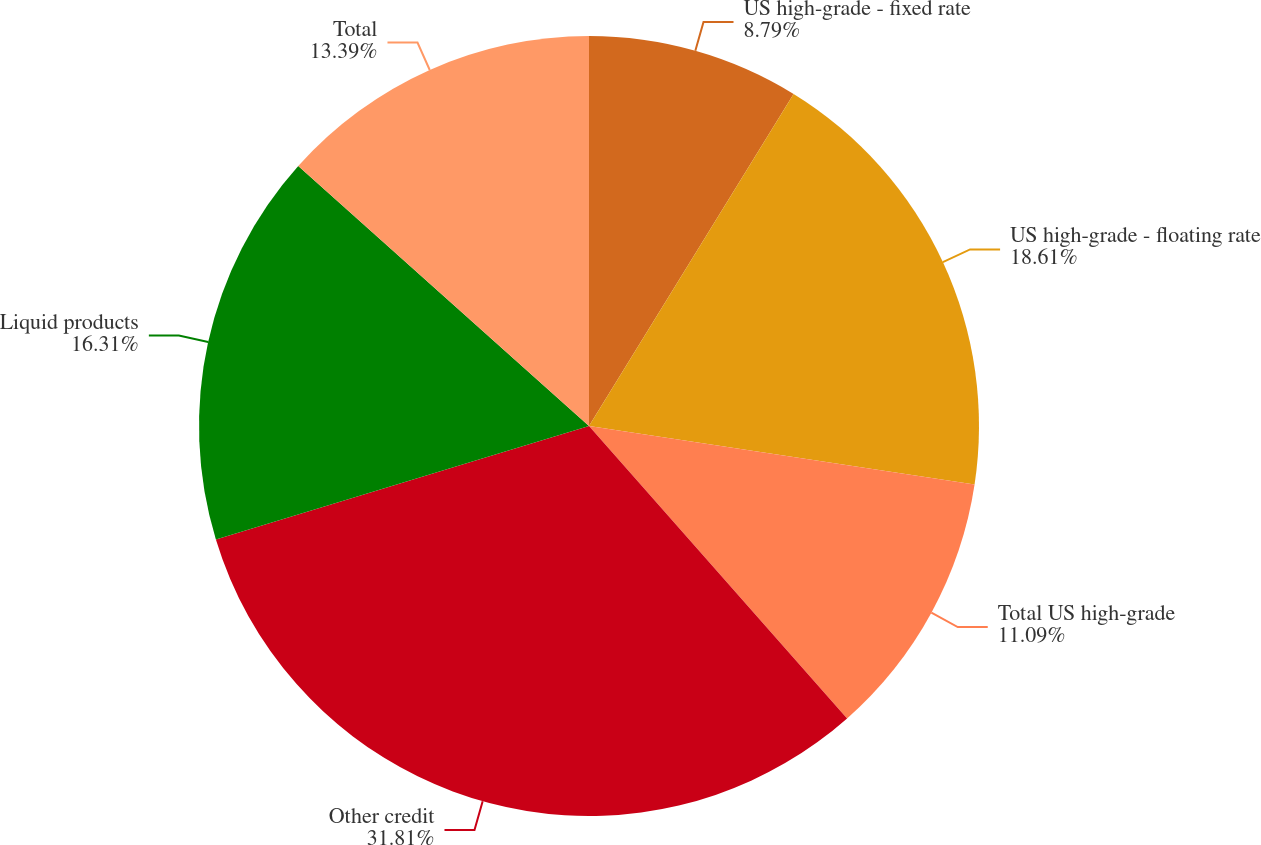Convert chart. <chart><loc_0><loc_0><loc_500><loc_500><pie_chart><fcel>US high-grade - fixed rate<fcel>US high-grade - floating rate<fcel>Total US high-grade<fcel>Other credit<fcel>Liquid products<fcel>Total<nl><fcel>8.79%<fcel>18.61%<fcel>11.09%<fcel>31.81%<fcel>16.31%<fcel>13.39%<nl></chart> 